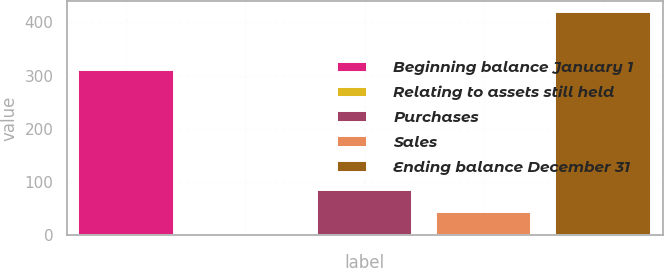<chart> <loc_0><loc_0><loc_500><loc_500><bar_chart><fcel>Beginning balance January 1<fcel>Relating to assets still held<fcel>Purchases<fcel>Sales<fcel>Ending balance December 31<nl><fcel>310<fcel>2<fcel>85.6<fcel>43.8<fcel>420<nl></chart> 